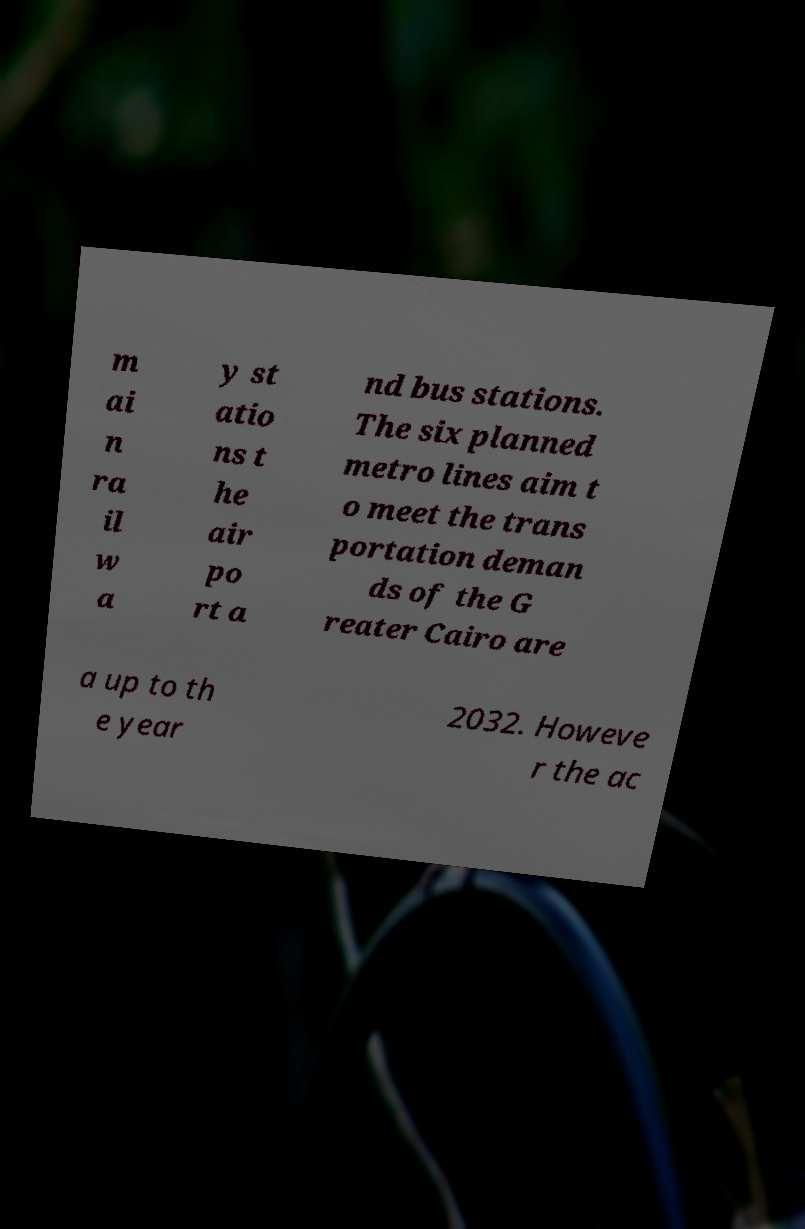Could you extract and type out the text from this image? m ai n ra il w a y st atio ns t he air po rt a nd bus stations. The six planned metro lines aim t o meet the trans portation deman ds of the G reater Cairo are a up to th e year 2032. Howeve r the ac 